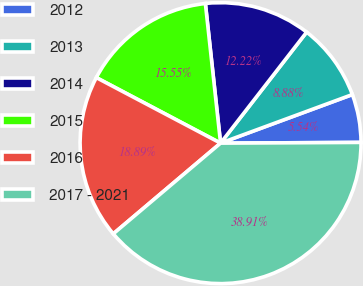<chart> <loc_0><loc_0><loc_500><loc_500><pie_chart><fcel>2012<fcel>2013<fcel>2014<fcel>2015<fcel>2016<fcel>2017 - 2021<nl><fcel>5.54%<fcel>8.88%<fcel>12.22%<fcel>15.55%<fcel>18.89%<fcel>38.91%<nl></chart> 